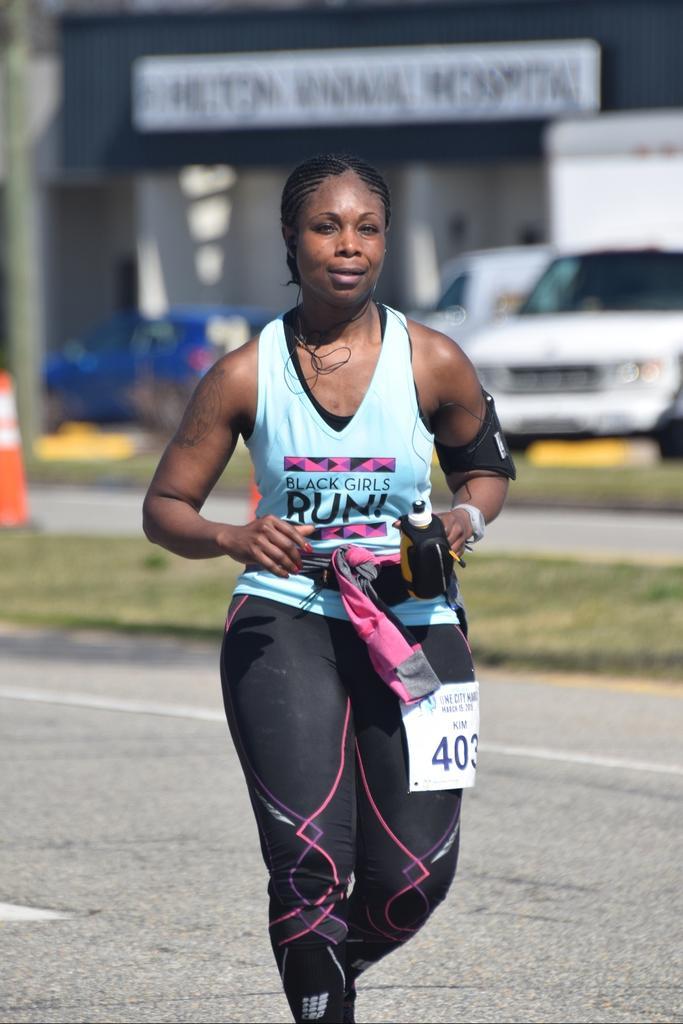Could you give a brief overview of what you see in this image? In this image we can see a lady holding something in the hand and having a chest number. In the background there is a car. Also there is a traffic cone. And it is looking blur in the background. 